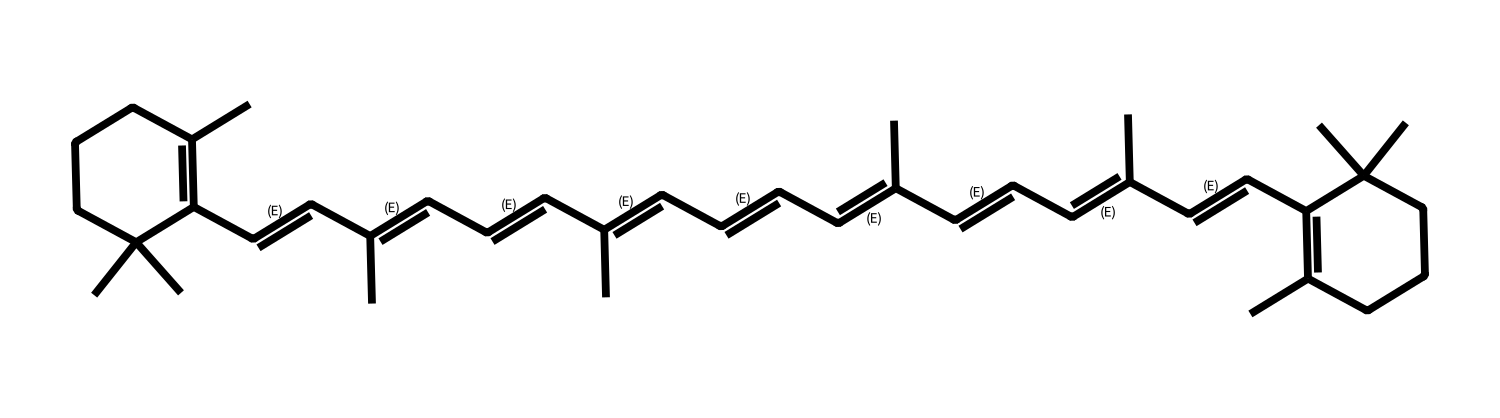What is the name of this chemical? The chemical structure represented by the provided SMILES corresponds to beta-carotene, a well-known antioxidant found in carrots and pumpkins.
Answer: beta-carotene How many carbon atoms are in beta-carotene? By analyzing the SMILES representation, we count the occurrences of carbon symbols (C) in the structure. There are 40 carbon atoms in beta-carotene.
Answer: 40 What type of compound is beta-carotene? Beta-carotene is classified as a carotenoid, which is a type of organic pigment found in plants; the large number of conjugated double bonds indicates its classification.
Answer: carotenoid How many double bonds does beta-carotene contain? The number of double bonds can be identified by checking for the presence of "C=C" segments in the SMILES; there are 11 double bonds indicated in the structure.
Answer: 11 What functional groups are involved in beta-carotene's structure? The structure primarily consists of multiple carbon-carbon double bonds and a long hydrocarbon chain; it lacks any specific functional groups like hydroxyl or carboxylic acids.
Answer: none Why does beta-carotene act as an antioxidant? The presence of conjugated double bonds allows beta-carotene to donate electrons and neutralize free radicals, hence acting as an antioxidant. This can be inferred from its structure, conducive to electron donation.
Answer: electron donation 